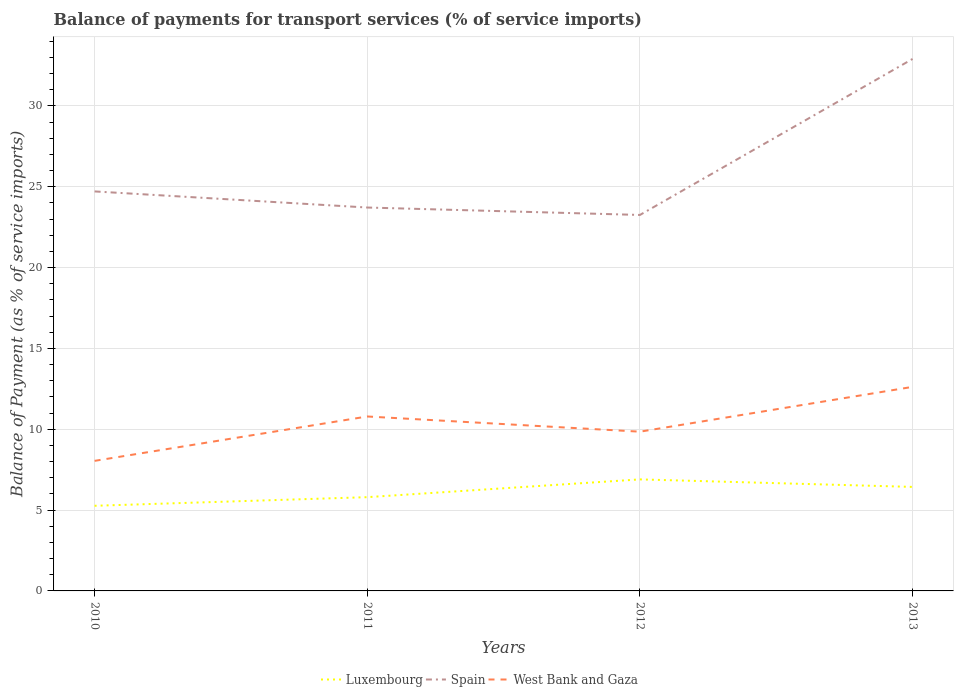How many different coloured lines are there?
Keep it short and to the point. 3. Does the line corresponding to Spain intersect with the line corresponding to Luxembourg?
Give a very brief answer. No. Is the number of lines equal to the number of legend labels?
Your answer should be very brief. Yes. Across all years, what is the maximum balance of payments for transport services in Luxembourg?
Your response must be concise. 5.27. In which year was the balance of payments for transport services in Luxembourg maximum?
Ensure brevity in your answer.  2010. What is the total balance of payments for transport services in West Bank and Gaza in the graph?
Keep it short and to the point. -1.8. What is the difference between the highest and the second highest balance of payments for transport services in Luxembourg?
Offer a very short reply. 1.63. Is the balance of payments for transport services in Spain strictly greater than the balance of payments for transport services in Luxembourg over the years?
Offer a very short reply. No. How many years are there in the graph?
Your answer should be compact. 4. Where does the legend appear in the graph?
Offer a terse response. Bottom center. How many legend labels are there?
Your answer should be compact. 3. What is the title of the graph?
Offer a very short reply. Balance of payments for transport services (% of service imports). Does "Congo (Republic)" appear as one of the legend labels in the graph?
Your response must be concise. No. What is the label or title of the Y-axis?
Offer a terse response. Balance of Payment (as % of service imports). What is the Balance of Payment (as % of service imports) in Luxembourg in 2010?
Make the answer very short. 5.27. What is the Balance of Payment (as % of service imports) of Spain in 2010?
Ensure brevity in your answer.  24.71. What is the Balance of Payment (as % of service imports) of West Bank and Gaza in 2010?
Ensure brevity in your answer.  8.04. What is the Balance of Payment (as % of service imports) of Luxembourg in 2011?
Your answer should be compact. 5.8. What is the Balance of Payment (as % of service imports) of Spain in 2011?
Ensure brevity in your answer.  23.71. What is the Balance of Payment (as % of service imports) in West Bank and Gaza in 2011?
Provide a short and direct response. 10.79. What is the Balance of Payment (as % of service imports) in Luxembourg in 2012?
Give a very brief answer. 6.9. What is the Balance of Payment (as % of service imports) in Spain in 2012?
Your response must be concise. 23.25. What is the Balance of Payment (as % of service imports) of West Bank and Gaza in 2012?
Offer a very short reply. 9.85. What is the Balance of Payment (as % of service imports) of Luxembourg in 2013?
Your answer should be compact. 6.43. What is the Balance of Payment (as % of service imports) of Spain in 2013?
Make the answer very short. 32.9. What is the Balance of Payment (as % of service imports) of West Bank and Gaza in 2013?
Offer a very short reply. 12.62. Across all years, what is the maximum Balance of Payment (as % of service imports) in Luxembourg?
Give a very brief answer. 6.9. Across all years, what is the maximum Balance of Payment (as % of service imports) in Spain?
Your answer should be compact. 32.9. Across all years, what is the maximum Balance of Payment (as % of service imports) of West Bank and Gaza?
Your answer should be very brief. 12.62. Across all years, what is the minimum Balance of Payment (as % of service imports) in Luxembourg?
Ensure brevity in your answer.  5.27. Across all years, what is the minimum Balance of Payment (as % of service imports) of Spain?
Keep it short and to the point. 23.25. Across all years, what is the minimum Balance of Payment (as % of service imports) of West Bank and Gaza?
Your answer should be very brief. 8.04. What is the total Balance of Payment (as % of service imports) of Luxembourg in the graph?
Give a very brief answer. 24.4. What is the total Balance of Payment (as % of service imports) in Spain in the graph?
Ensure brevity in your answer.  104.57. What is the total Balance of Payment (as % of service imports) of West Bank and Gaza in the graph?
Your answer should be compact. 41.3. What is the difference between the Balance of Payment (as % of service imports) of Luxembourg in 2010 and that in 2011?
Your response must be concise. -0.53. What is the difference between the Balance of Payment (as % of service imports) of West Bank and Gaza in 2010 and that in 2011?
Give a very brief answer. -2.74. What is the difference between the Balance of Payment (as % of service imports) in Luxembourg in 2010 and that in 2012?
Make the answer very short. -1.63. What is the difference between the Balance of Payment (as % of service imports) of Spain in 2010 and that in 2012?
Your answer should be compact. 1.46. What is the difference between the Balance of Payment (as % of service imports) in West Bank and Gaza in 2010 and that in 2012?
Provide a short and direct response. -1.8. What is the difference between the Balance of Payment (as % of service imports) of Luxembourg in 2010 and that in 2013?
Provide a succinct answer. -1.17. What is the difference between the Balance of Payment (as % of service imports) in Spain in 2010 and that in 2013?
Provide a succinct answer. -8.2. What is the difference between the Balance of Payment (as % of service imports) in West Bank and Gaza in 2010 and that in 2013?
Keep it short and to the point. -4.58. What is the difference between the Balance of Payment (as % of service imports) of Luxembourg in 2011 and that in 2012?
Your answer should be compact. -1.1. What is the difference between the Balance of Payment (as % of service imports) of Spain in 2011 and that in 2012?
Offer a very short reply. 0.46. What is the difference between the Balance of Payment (as % of service imports) of West Bank and Gaza in 2011 and that in 2012?
Make the answer very short. 0.94. What is the difference between the Balance of Payment (as % of service imports) in Luxembourg in 2011 and that in 2013?
Make the answer very short. -0.63. What is the difference between the Balance of Payment (as % of service imports) in Spain in 2011 and that in 2013?
Provide a short and direct response. -9.19. What is the difference between the Balance of Payment (as % of service imports) of West Bank and Gaza in 2011 and that in 2013?
Provide a short and direct response. -1.83. What is the difference between the Balance of Payment (as % of service imports) in Luxembourg in 2012 and that in 2013?
Make the answer very short. 0.46. What is the difference between the Balance of Payment (as % of service imports) of Spain in 2012 and that in 2013?
Your response must be concise. -9.65. What is the difference between the Balance of Payment (as % of service imports) in West Bank and Gaza in 2012 and that in 2013?
Your answer should be compact. -2.77. What is the difference between the Balance of Payment (as % of service imports) in Luxembourg in 2010 and the Balance of Payment (as % of service imports) in Spain in 2011?
Offer a very short reply. -18.45. What is the difference between the Balance of Payment (as % of service imports) in Luxembourg in 2010 and the Balance of Payment (as % of service imports) in West Bank and Gaza in 2011?
Provide a succinct answer. -5.52. What is the difference between the Balance of Payment (as % of service imports) of Spain in 2010 and the Balance of Payment (as % of service imports) of West Bank and Gaza in 2011?
Your answer should be very brief. 13.92. What is the difference between the Balance of Payment (as % of service imports) in Luxembourg in 2010 and the Balance of Payment (as % of service imports) in Spain in 2012?
Provide a succinct answer. -17.99. What is the difference between the Balance of Payment (as % of service imports) of Luxembourg in 2010 and the Balance of Payment (as % of service imports) of West Bank and Gaza in 2012?
Provide a short and direct response. -4.58. What is the difference between the Balance of Payment (as % of service imports) of Spain in 2010 and the Balance of Payment (as % of service imports) of West Bank and Gaza in 2012?
Keep it short and to the point. 14.86. What is the difference between the Balance of Payment (as % of service imports) of Luxembourg in 2010 and the Balance of Payment (as % of service imports) of Spain in 2013?
Your answer should be very brief. -27.64. What is the difference between the Balance of Payment (as % of service imports) in Luxembourg in 2010 and the Balance of Payment (as % of service imports) in West Bank and Gaza in 2013?
Offer a terse response. -7.35. What is the difference between the Balance of Payment (as % of service imports) of Spain in 2010 and the Balance of Payment (as % of service imports) of West Bank and Gaza in 2013?
Your answer should be very brief. 12.09. What is the difference between the Balance of Payment (as % of service imports) in Luxembourg in 2011 and the Balance of Payment (as % of service imports) in Spain in 2012?
Your answer should be very brief. -17.45. What is the difference between the Balance of Payment (as % of service imports) in Luxembourg in 2011 and the Balance of Payment (as % of service imports) in West Bank and Gaza in 2012?
Your answer should be compact. -4.05. What is the difference between the Balance of Payment (as % of service imports) in Spain in 2011 and the Balance of Payment (as % of service imports) in West Bank and Gaza in 2012?
Your response must be concise. 13.86. What is the difference between the Balance of Payment (as % of service imports) of Luxembourg in 2011 and the Balance of Payment (as % of service imports) of Spain in 2013?
Ensure brevity in your answer.  -27.1. What is the difference between the Balance of Payment (as % of service imports) of Luxembourg in 2011 and the Balance of Payment (as % of service imports) of West Bank and Gaza in 2013?
Give a very brief answer. -6.82. What is the difference between the Balance of Payment (as % of service imports) in Spain in 2011 and the Balance of Payment (as % of service imports) in West Bank and Gaza in 2013?
Your answer should be very brief. 11.09. What is the difference between the Balance of Payment (as % of service imports) of Luxembourg in 2012 and the Balance of Payment (as % of service imports) of Spain in 2013?
Provide a short and direct response. -26. What is the difference between the Balance of Payment (as % of service imports) of Luxembourg in 2012 and the Balance of Payment (as % of service imports) of West Bank and Gaza in 2013?
Offer a very short reply. -5.72. What is the difference between the Balance of Payment (as % of service imports) in Spain in 2012 and the Balance of Payment (as % of service imports) in West Bank and Gaza in 2013?
Provide a succinct answer. 10.63. What is the average Balance of Payment (as % of service imports) of Luxembourg per year?
Offer a terse response. 6.1. What is the average Balance of Payment (as % of service imports) of Spain per year?
Offer a very short reply. 26.14. What is the average Balance of Payment (as % of service imports) of West Bank and Gaza per year?
Provide a short and direct response. 10.33. In the year 2010, what is the difference between the Balance of Payment (as % of service imports) in Luxembourg and Balance of Payment (as % of service imports) in Spain?
Keep it short and to the point. -19.44. In the year 2010, what is the difference between the Balance of Payment (as % of service imports) of Luxembourg and Balance of Payment (as % of service imports) of West Bank and Gaza?
Provide a succinct answer. -2.78. In the year 2010, what is the difference between the Balance of Payment (as % of service imports) of Spain and Balance of Payment (as % of service imports) of West Bank and Gaza?
Make the answer very short. 16.66. In the year 2011, what is the difference between the Balance of Payment (as % of service imports) in Luxembourg and Balance of Payment (as % of service imports) in Spain?
Keep it short and to the point. -17.91. In the year 2011, what is the difference between the Balance of Payment (as % of service imports) in Luxembourg and Balance of Payment (as % of service imports) in West Bank and Gaza?
Give a very brief answer. -4.99. In the year 2011, what is the difference between the Balance of Payment (as % of service imports) of Spain and Balance of Payment (as % of service imports) of West Bank and Gaza?
Give a very brief answer. 12.92. In the year 2012, what is the difference between the Balance of Payment (as % of service imports) of Luxembourg and Balance of Payment (as % of service imports) of Spain?
Provide a short and direct response. -16.35. In the year 2012, what is the difference between the Balance of Payment (as % of service imports) of Luxembourg and Balance of Payment (as % of service imports) of West Bank and Gaza?
Offer a terse response. -2.95. In the year 2012, what is the difference between the Balance of Payment (as % of service imports) of Spain and Balance of Payment (as % of service imports) of West Bank and Gaza?
Your answer should be compact. 13.4. In the year 2013, what is the difference between the Balance of Payment (as % of service imports) in Luxembourg and Balance of Payment (as % of service imports) in Spain?
Offer a very short reply. -26.47. In the year 2013, what is the difference between the Balance of Payment (as % of service imports) of Luxembourg and Balance of Payment (as % of service imports) of West Bank and Gaza?
Ensure brevity in your answer.  -6.19. In the year 2013, what is the difference between the Balance of Payment (as % of service imports) in Spain and Balance of Payment (as % of service imports) in West Bank and Gaza?
Your answer should be very brief. 20.28. What is the ratio of the Balance of Payment (as % of service imports) in Luxembourg in 2010 to that in 2011?
Your response must be concise. 0.91. What is the ratio of the Balance of Payment (as % of service imports) in Spain in 2010 to that in 2011?
Provide a short and direct response. 1.04. What is the ratio of the Balance of Payment (as % of service imports) of West Bank and Gaza in 2010 to that in 2011?
Offer a terse response. 0.75. What is the ratio of the Balance of Payment (as % of service imports) in Luxembourg in 2010 to that in 2012?
Your response must be concise. 0.76. What is the ratio of the Balance of Payment (as % of service imports) in Spain in 2010 to that in 2012?
Give a very brief answer. 1.06. What is the ratio of the Balance of Payment (as % of service imports) of West Bank and Gaza in 2010 to that in 2012?
Provide a short and direct response. 0.82. What is the ratio of the Balance of Payment (as % of service imports) of Luxembourg in 2010 to that in 2013?
Your answer should be very brief. 0.82. What is the ratio of the Balance of Payment (as % of service imports) in Spain in 2010 to that in 2013?
Offer a terse response. 0.75. What is the ratio of the Balance of Payment (as % of service imports) of West Bank and Gaza in 2010 to that in 2013?
Your answer should be very brief. 0.64. What is the ratio of the Balance of Payment (as % of service imports) in Luxembourg in 2011 to that in 2012?
Make the answer very short. 0.84. What is the ratio of the Balance of Payment (as % of service imports) in Spain in 2011 to that in 2012?
Make the answer very short. 1.02. What is the ratio of the Balance of Payment (as % of service imports) in West Bank and Gaza in 2011 to that in 2012?
Offer a terse response. 1.1. What is the ratio of the Balance of Payment (as % of service imports) in Luxembourg in 2011 to that in 2013?
Offer a very short reply. 0.9. What is the ratio of the Balance of Payment (as % of service imports) in Spain in 2011 to that in 2013?
Keep it short and to the point. 0.72. What is the ratio of the Balance of Payment (as % of service imports) of West Bank and Gaza in 2011 to that in 2013?
Your response must be concise. 0.85. What is the ratio of the Balance of Payment (as % of service imports) of Luxembourg in 2012 to that in 2013?
Provide a short and direct response. 1.07. What is the ratio of the Balance of Payment (as % of service imports) in Spain in 2012 to that in 2013?
Provide a succinct answer. 0.71. What is the ratio of the Balance of Payment (as % of service imports) of West Bank and Gaza in 2012 to that in 2013?
Offer a terse response. 0.78. What is the difference between the highest and the second highest Balance of Payment (as % of service imports) in Luxembourg?
Your answer should be compact. 0.46. What is the difference between the highest and the second highest Balance of Payment (as % of service imports) of Spain?
Provide a succinct answer. 8.2. What is the difference between the highest and the second highest Balance of Payment (as % of service imports) of West Bank and Gaza?
Offer a very short reply. 1.83. What is the difference between the highest and the lowest Balance of Payment (as % of service imports) of Luxembourg?
Offer a very short reply. 1.63. What is the difference between the highest and the lowest Balance of Payment (as % of service imports) in Spain?
Provide a succinct answer. 9.65. What is the difference between the highest and the lowest Balance of Payment (as % of service imports) in West Bank and Gaza?
Ensure brevity in your answer.  4.58. 